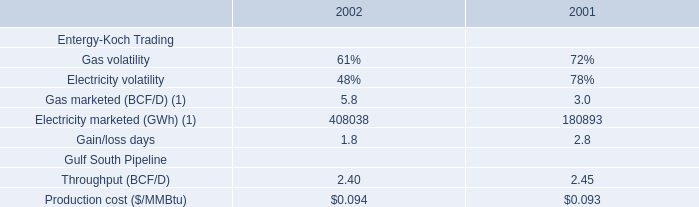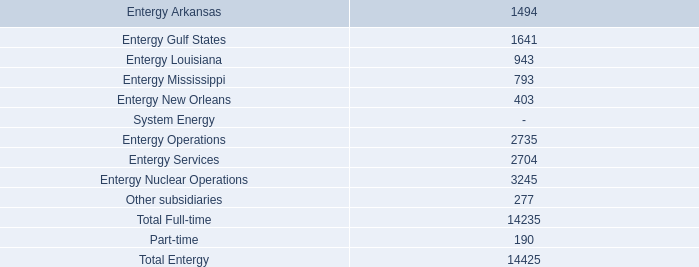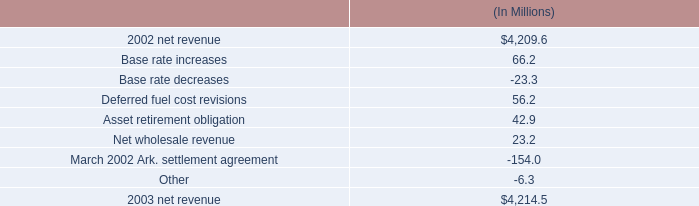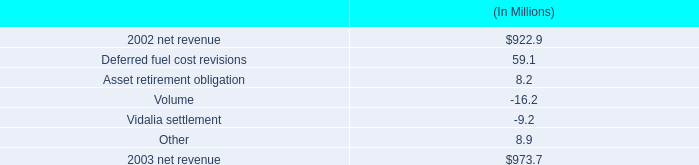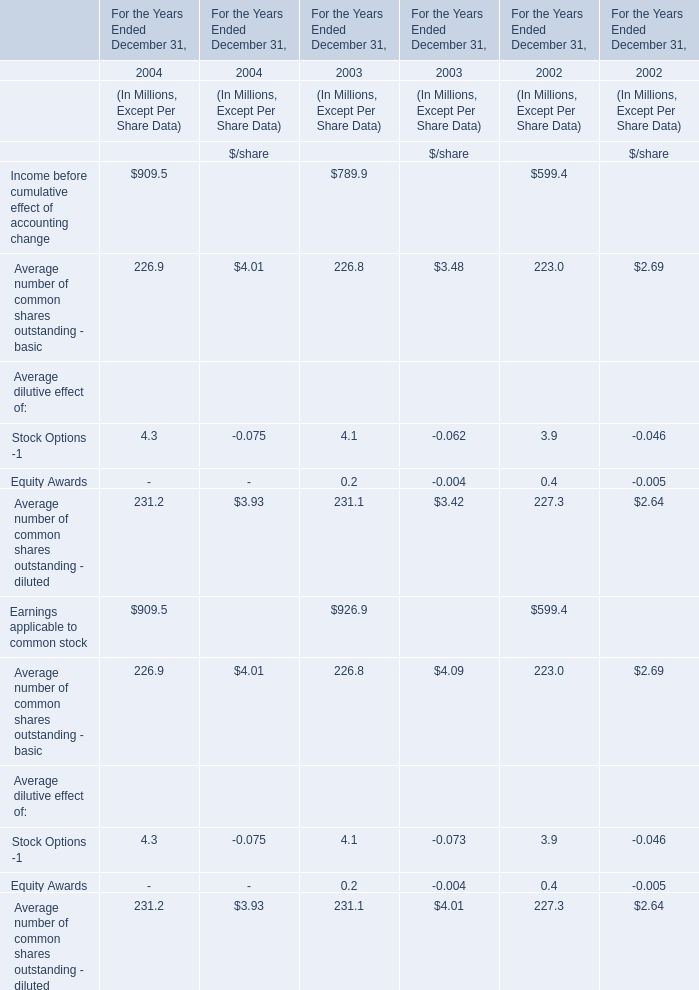what is the growth rate in net revenue in 2003 for entergy corporation? 
Computations: ((4214.5 - 4209.6) / 4209.6)
Answer: 0.00116. 